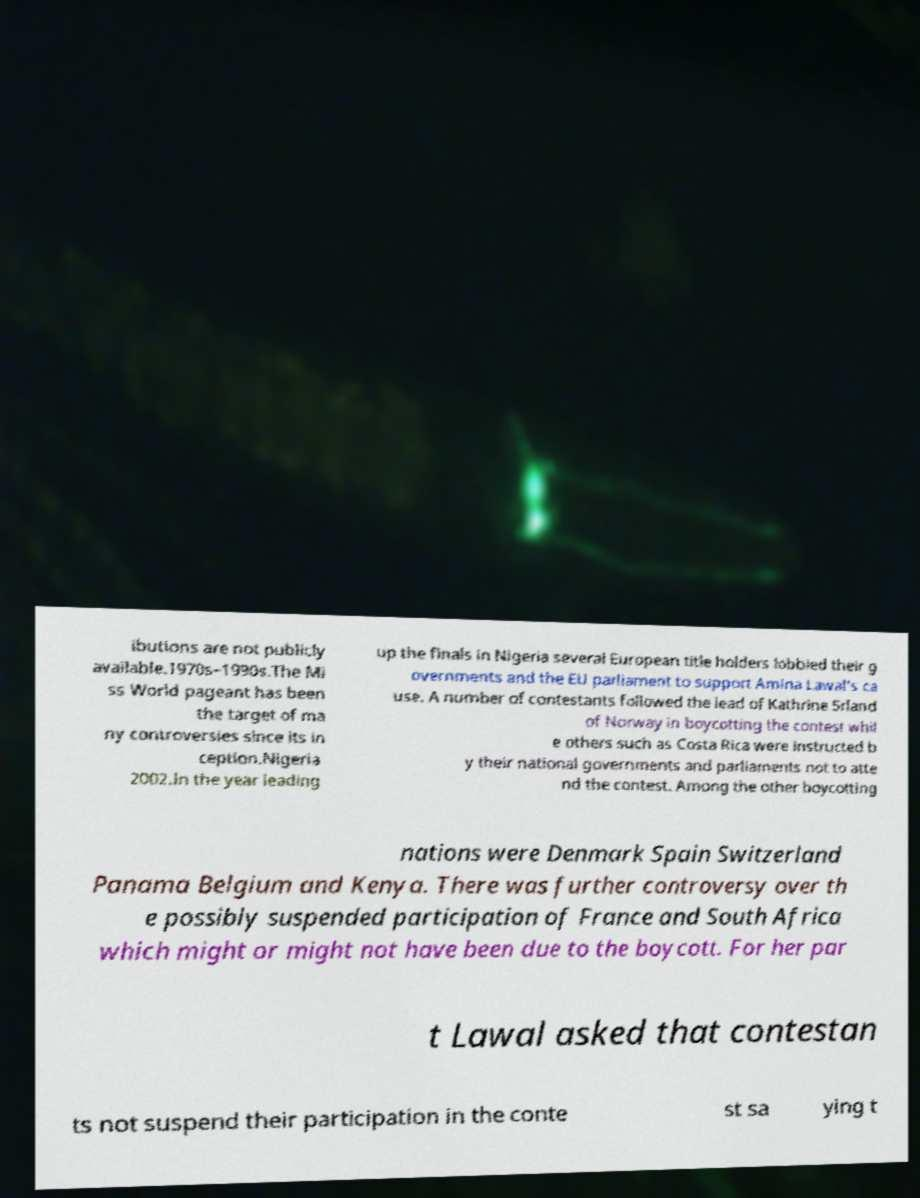Could you assist in decoding the text presented in this image and type it out clearly? ibutions are not publicly available.1970s–1990s.The Mi ss World pageant has been the target of ma ny controversies since its in ception.Nigeria 2002.In the year leading up the finals in Nigeria several European title holders lobbied their g overnments and the EU parliament to support Amina Lawal's ca use. A number of contestants followed the lead of Kathrine Srland of Norway in boycotting the contest whil e others such as Costa Rica were instructed b y their national governments and parliaments not to atte nd the contest. Among the other boycotting nations were Denmark Spain Switzerland Panama Belgium and Kenya. There was further controversy over th e possibly suspended participation of France and South Africa which might or might not have been due to the boycott. For her par t Lawal asked that contestan ts not suspend their participation in the conte st sa ying t 